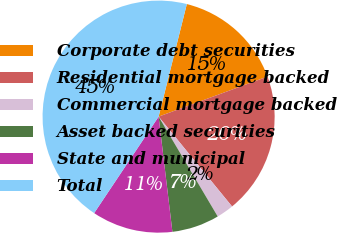<chart> <loc_0><loc_0><loc_500><loc_500><pie_chart><fcel>Corporate debt securities<fcel>Residential mortgage backed<fcel>Commercial mortgage backed<fcel>Asset backed securities<fcel>State and municipal<fcel>Total<nl><fcel>15.48%<fcel>19.7%<fcel>2.4%<fcel>6.61%<fcel>11.27%<fcel>44.53%<nl></chart> 